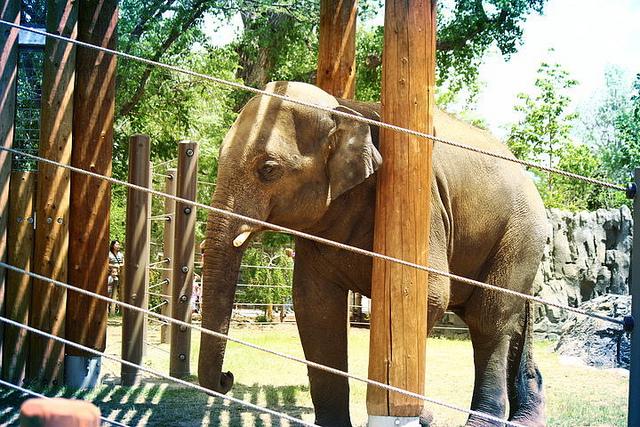Does the elephant have tusks?
Give a very brief answer. Yes. What color is the elephant?
Write a very short answer. Gray. How many legs does this elephant have?
Be succinct. 4. 